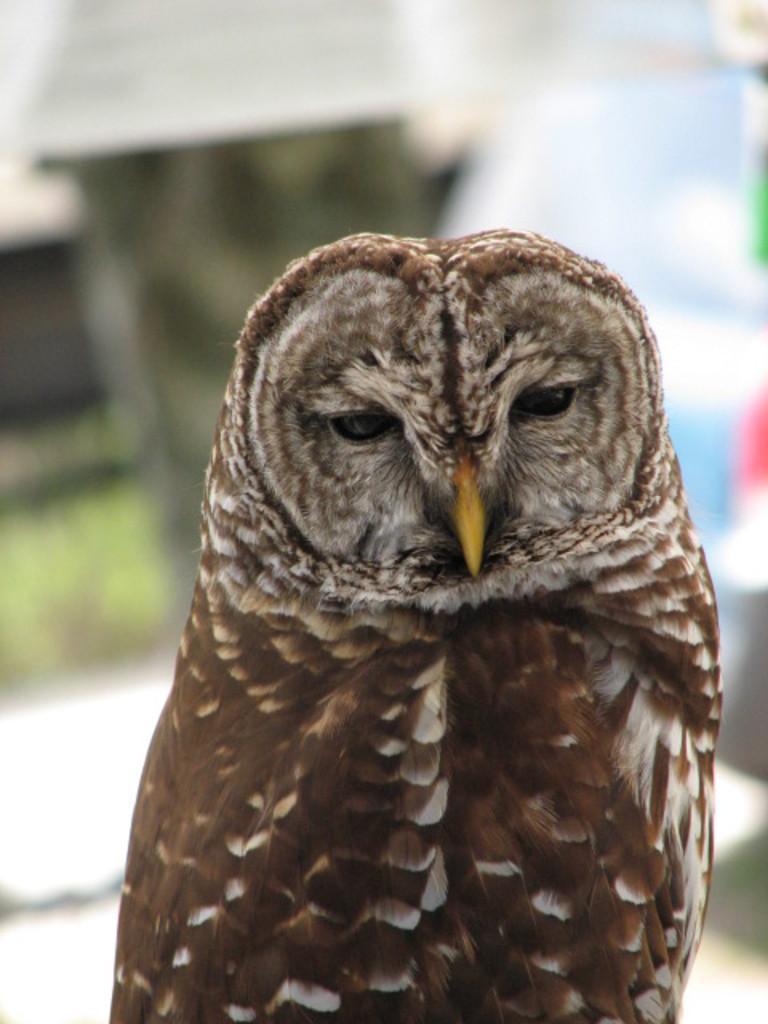How would you summarize this image in a sentence or two? In the image there is an owl standing in the front and the background is blurry. 